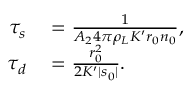<formula> <loc_0><loc_0><loc_500><loc_500>\begin{array} { r l } { \tau _ { s } } & = \frac { 1 } { A _ { 2 } 4 \pi \rho _ { L } K ^ { \prime } r _ { 0 } n _ { 0 } } , } \\ { \tau _ { d } } & = \frac { r _ { 0 } ^ { 2 } } { 2 K ^ { \prime } | s _ { 0 } | } . } \end{array}</formula> 